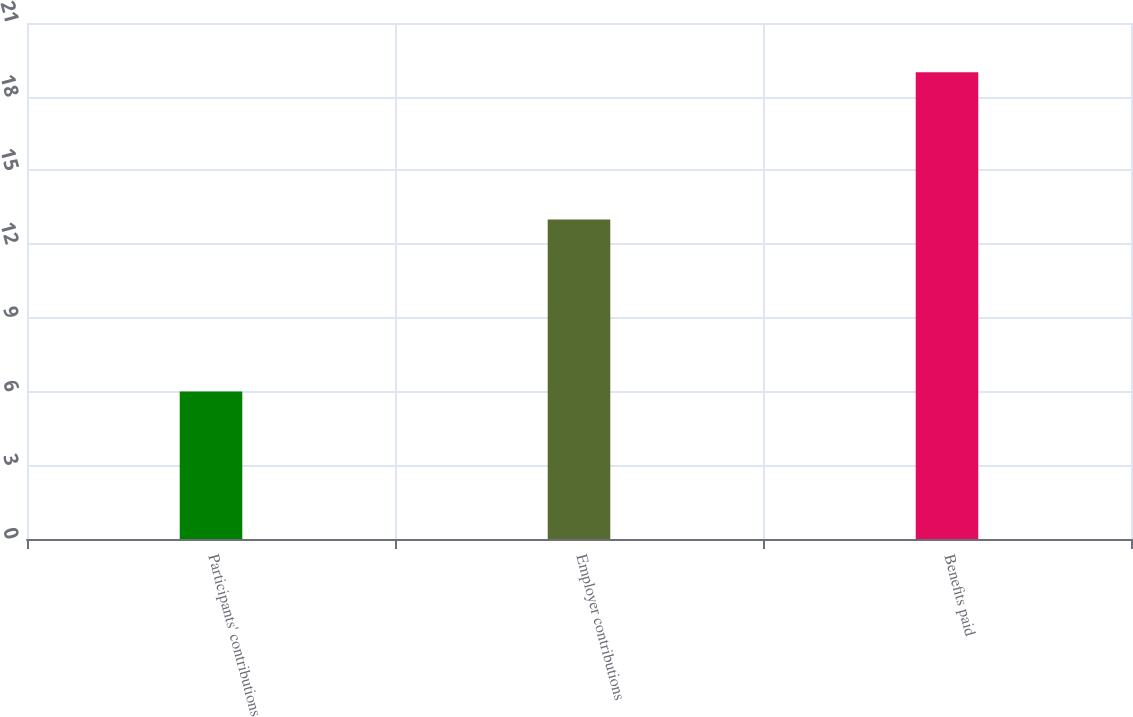Convert chart to OTSL. <chart><loc_0><loc_0><loc_500><loc_500><bar_chart><fcel>Participants' contributions<fcel>Employer contributions<fcel>Benefits paid<nl><fcel>6<fcel>13<fcel>19<nl></chart> 